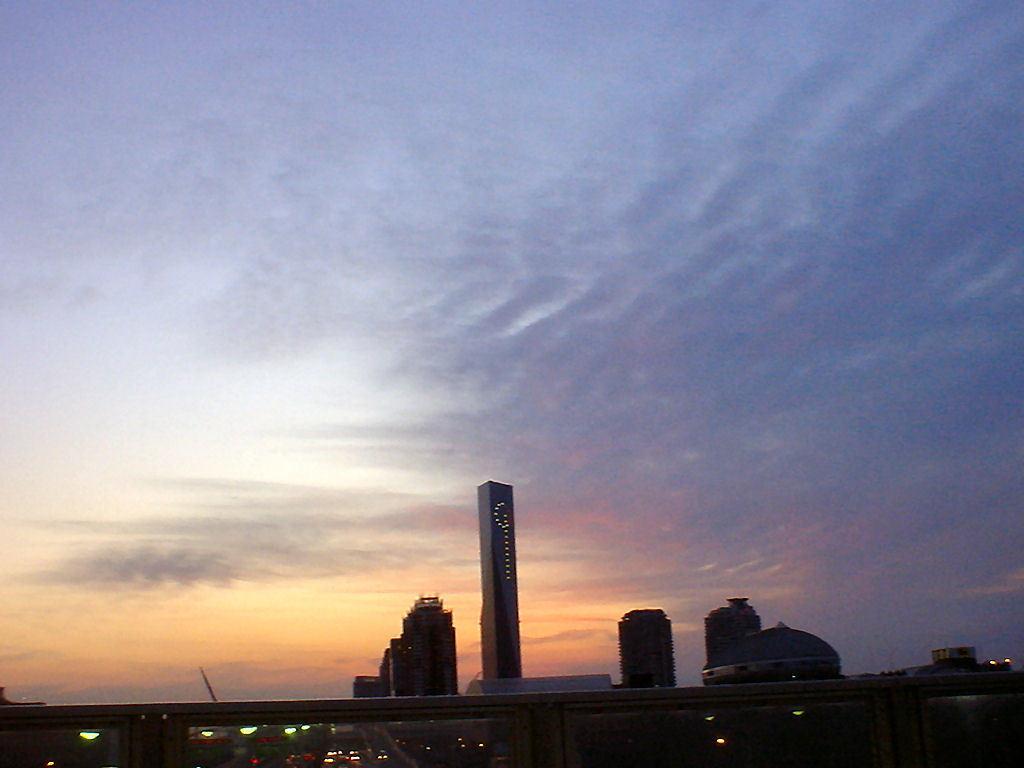Please provide a concise description of this image. In this image we can see a group of buildings, lights and in the background, we can see the cloudy sky. 